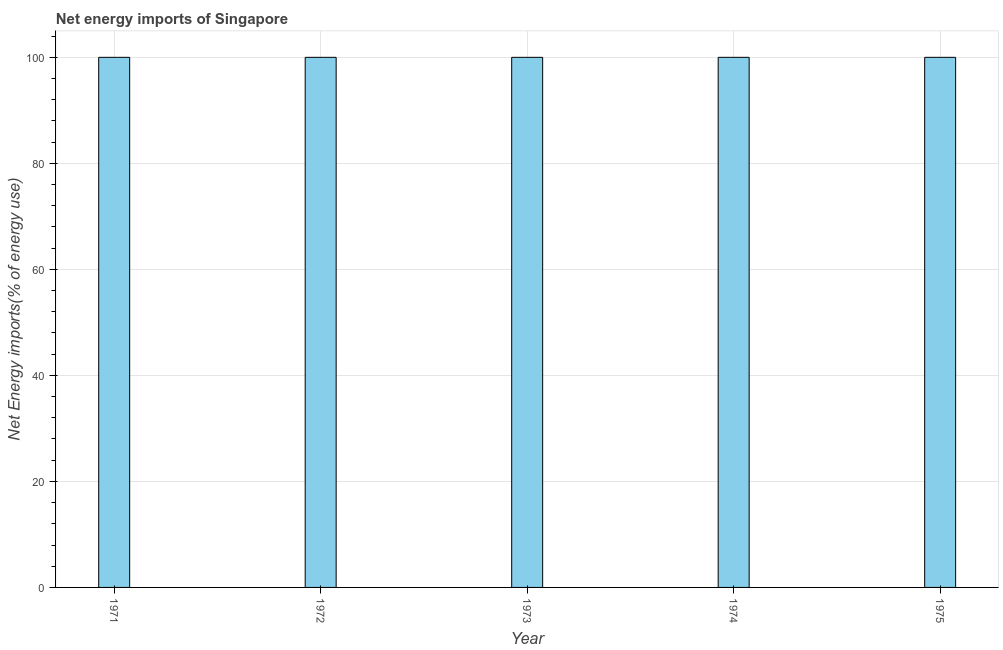Does the graph contain grids?
Your answer should be very brief. Yes. What is the title of the graph?
Your response must be concise. Net energy imports of Singapore. What is the label or title of the X-axis?
Ensure brevity in your answer.  Year. What is the label or title of the Y-axis?
Give a very brief answer. Net Energy imports(% of energy use). What is the energy imports in 1975?
Your answer should be very brief. 100. Across all years, what is the maximum energy imports?
Your response must be concise. 100. Across all years, what is the minimum energy imports?
Offer a terse response. 100. In which year was the energy imports maximum?
Keep it short and to the point. 1971. What is the sum of the energy imports?
Make the answer very short. 500. What is the difference between the energy imports in 1973 and 1974?
Provide a succinct answer. 0. What is the average energy imports per year?
Your answer should be very brief. 100. Do a majority of the years between 1974 and 1973 (inclusive) have energy imports greater than 20 %?
Give a very brief answer. No. Is the difference between the energy imports in 1971 and 1975 greater than the difference between any two years?
Make the answer very short. Yes. What is the difference between the highest and the second highest energy imports?
Offer a terse response. 0. What is the difference between the highest and the lowest energy imports?
Provide a succinct answer. 0. In how many years, is the energy imports greater than the average energy imports taken over all years?
Offer a very short reply. 0. What is the difference between two consecutive major ticks on the Y-axis?
Keep it short and to the point. 20. Are the values on the major ticks of Y-axis written in scientific E-notation?
Keep it short and to the point. No. What is the Net Energy imports(% of energy use) of 1973?
Ensure brevity in your answer.  100. What is the difference between the Net Energy imports(% of energy use) in 1971 and 1974?
Make the answer very short. 0. What is the difference between the Net Energy imports(% of energy use) in 1971 and 1975?
Give a very brief answer. 0. What is the difference between the Net Energy imports(% of energy use) in 1972 and 1973?
Provide a succinct answer. 0. What is the difference between the Net Energy imports(% of energy use) in 1972 and 1974?
Your answer should be compact. 0. What is the difference between the Net Energy imports(% of energy use) in 1972 and 1975?
Keep it short and to the point. 0. What is the difference between the Net Energy imports(% of energy use) in 1973 and 1974?
Your answer should be very brief. 0. What is the difference between the Net Energy imports(% of energy use) in 1973 and 1975?
Your response must be concise. 0. What is the ratio of the Net Energy imports(% of energy use) in 1971 to that in 1972?
Give a very brief answer. 1. What is the ratio of the Net Energy imports(% of energy use) in 1971 to that in 1973?
Ensure brevity in your answer.  1. What is the ratio of the Net Energy imports(% of energy use) in 1972 to that in 1973?
Offer a terse response. 1. What is the ratio of the Net Energy imports(% of energy use) in 1972 to that in 1975?
Keep it short and to the point. 1. What is the ratio of the Net Energy imports(% of energy use) in 1973 to that in 1975?
Make the answer very short. 1. 